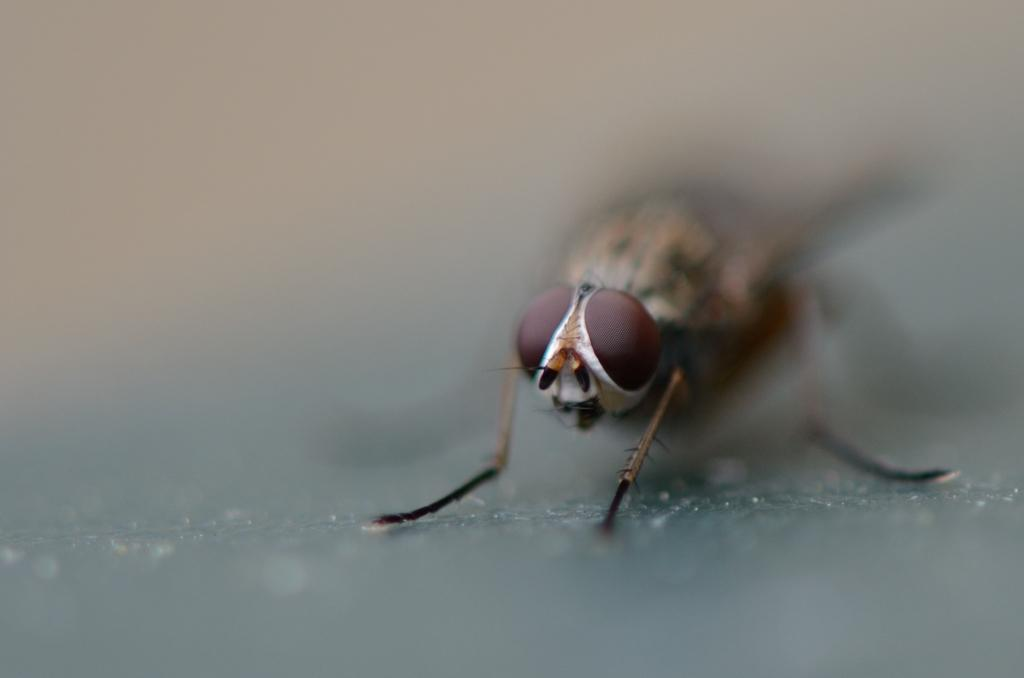What insect can be seen on the right side of the image? There is a bee on the right side of the image. Can you describe the background of the image? The background of the image is blurred. What type of protest is the bee participating in on the right side of the image? There is no protest present in the image; it features a bee on the right side. What level of difficulty does the bee face in the image? There is no indication of difficulty or challenge for the bee in the image; it is simply a bee on the right side. 